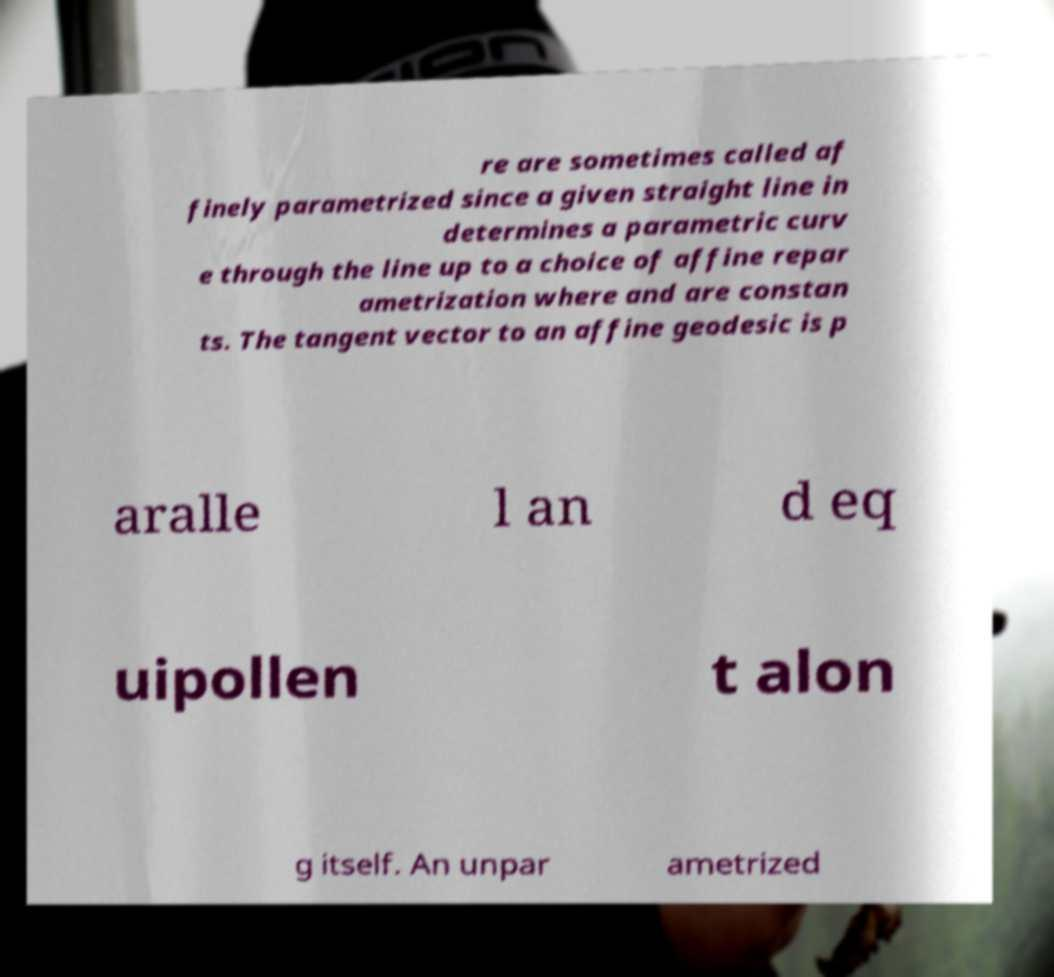For documentation purposes, I need the text within this image transcribed. Could you provide that? re are sometimes called af finely parametrized since a given straight line in determines a parametric curv e through the line up to a choice of affine repar ametrization where and are constan ts. The tangent vector to an affine geodesic is p aralle l an d eq uipollen t alon g itself. An unpar ametrized 